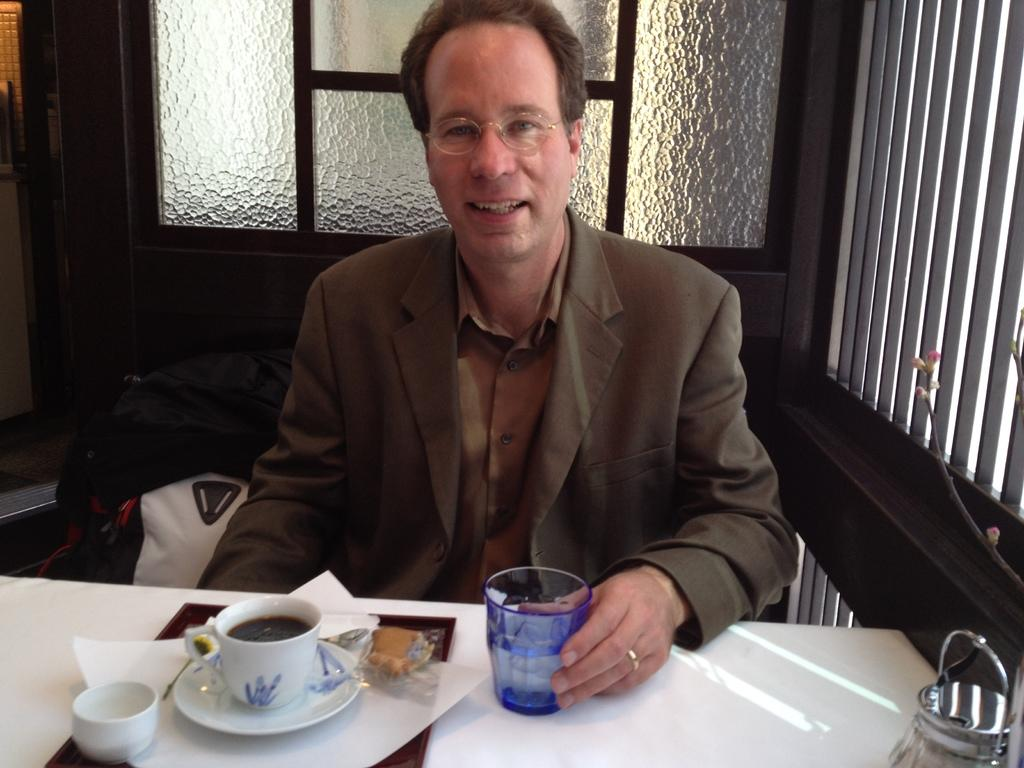Who is present in the image? There is a man in the image. What is the man wearing? The man is wearing a suit. What is the man doing in the image? The man is sitting on a chair. What is in front of the man? There is a table in front of the man. What is on the table? There is a tray, a cup, a saucer, and a glass on the table. What is behind the man? There is a glass window behind the man. What type of animal can be seen playing with an orange on the table? There is no animal or orange present on the table in the image. Is there a chicken on the chair next to the man? No, there is no chicken present in the image. 